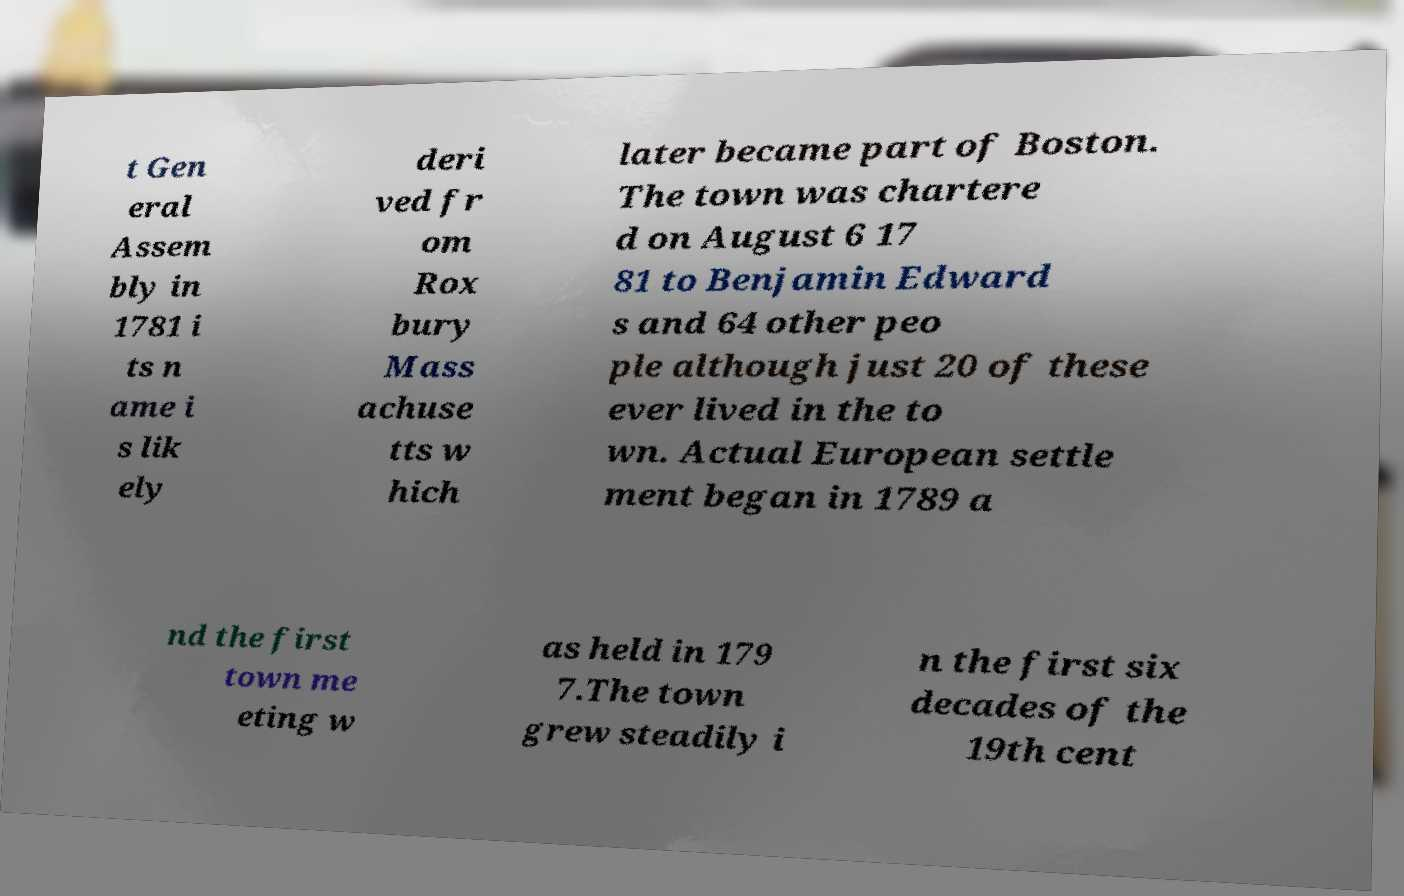What messages or text are displayed in this image? I need them in a readable, typed format. t Gen eral Assem bly in 1781 i ts n ame i s lik ely deri ved fr om Rox bury Mass achuse tts w hich later became part of Boston. The town was chartere d on August 6 17 81 to Benjamin Edward s and 64 other peo ple although just 20 of these ever lived in the to wn. Actual European settle ment began in 1789 a nd the first town me eting w as held in 179 7.The town grew steadily i n the first six decades of the 19th cent 